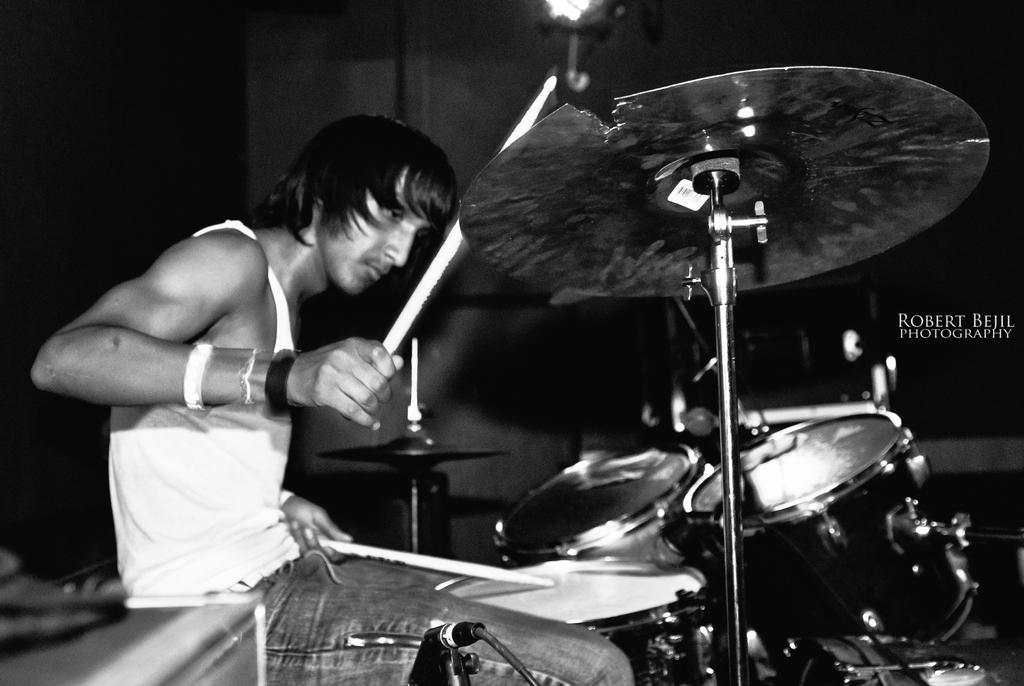How would you summarize this image in a sentence or two? In this image I can see the black and white picture in which I can see a person is sitting and holding sticks in his hands. I can see few musical instruments in front of him. I can see the dark background and a light. 